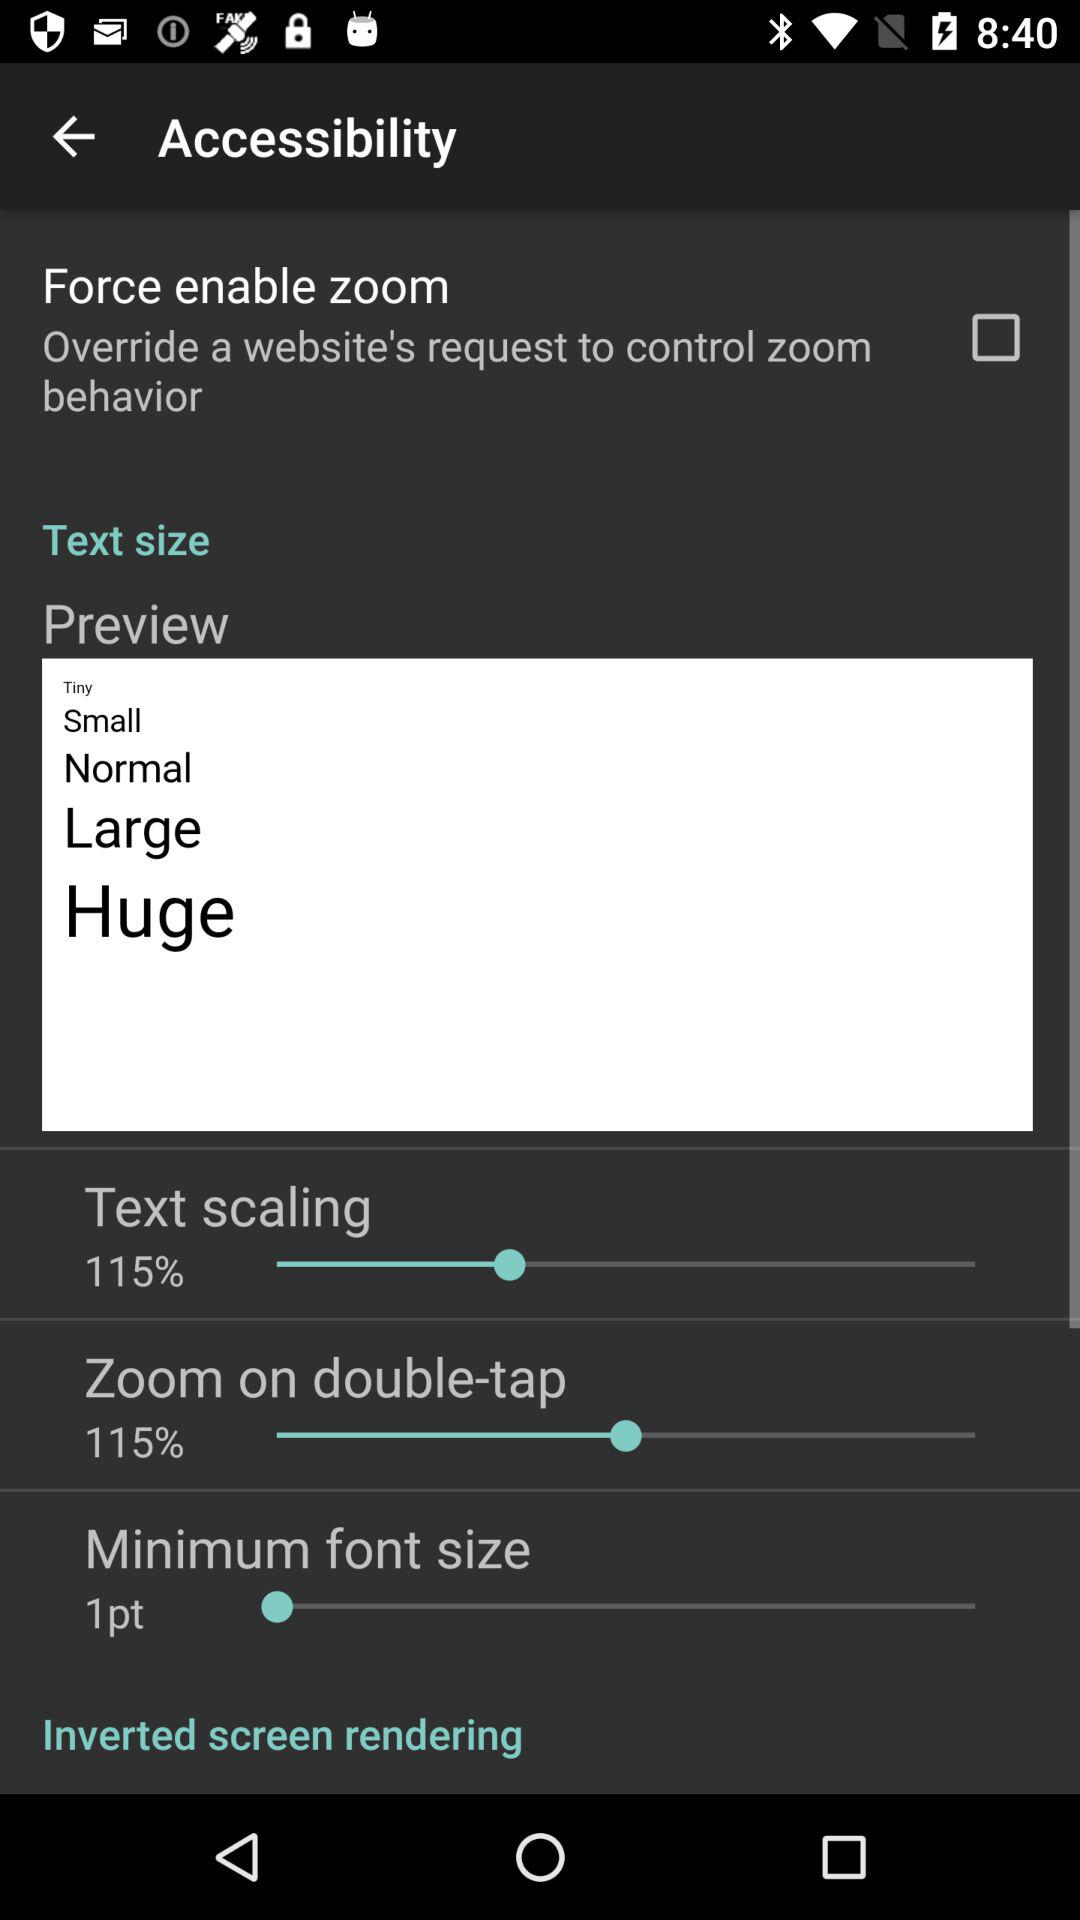How many text sizes does the user have to choose from?
Answer the question using a single word or phrase. 5 